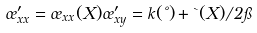Convert formula to latex. <formula><loc_0><loc_0><loc_500><loc_500>\sigma ^ { \prime } _ { x x } = \sigma _ { x x } ( X ) \sigma ^ { \prime } _ { x y } = k ( \nu ) + { \theta ( X ) } / { 2 \pi }</formula> 